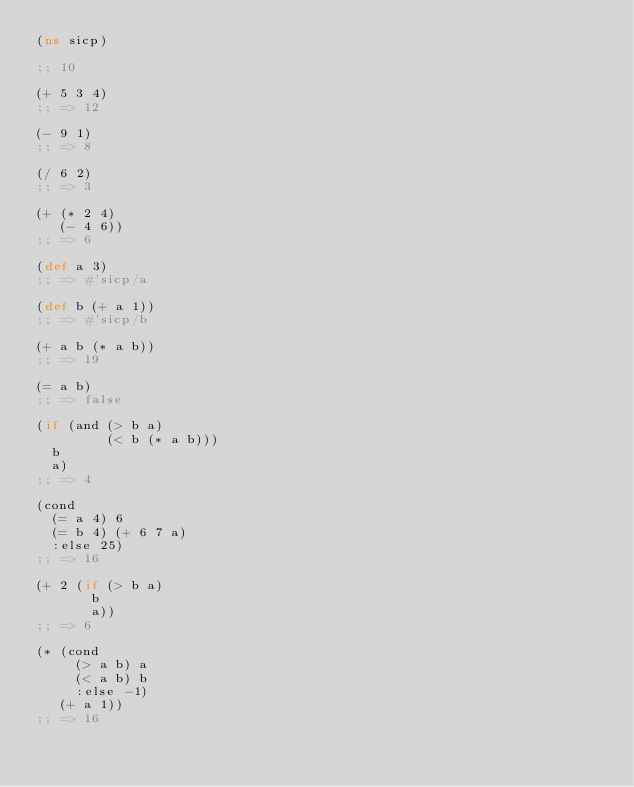<code> <loc_0><loc_0><loc_500><loc_500><_Clojure_>(ns sicp)

;; 10

(+ 5 3 4)
;; => 12

(- 9 1)
;; => 8

(/ 6 2)
;; => 3

(+ (* 2 4)
   (- 4 6))
;; => 6

(def a 3)
;; => #'sicp/a

(def b (+ a 1))
;; => #'sicp/b

(+ a b (* a b))
;; => 19

(= a b)
;; => false

(if (and (> b a)
         (< b (* a b)))
  b
  a)
;; => 4

(cond
  (= a 4) 6
  (= b 4) (+ 6 7 a)
  :else 25)
;; => 16

(+ 2 (if (> b a)
       b
       a))
;; => 6

(* (cond
     (> a b) a
     (< a b) b
     :else -1)
   (+ a 1))
;; => 16

</code> 